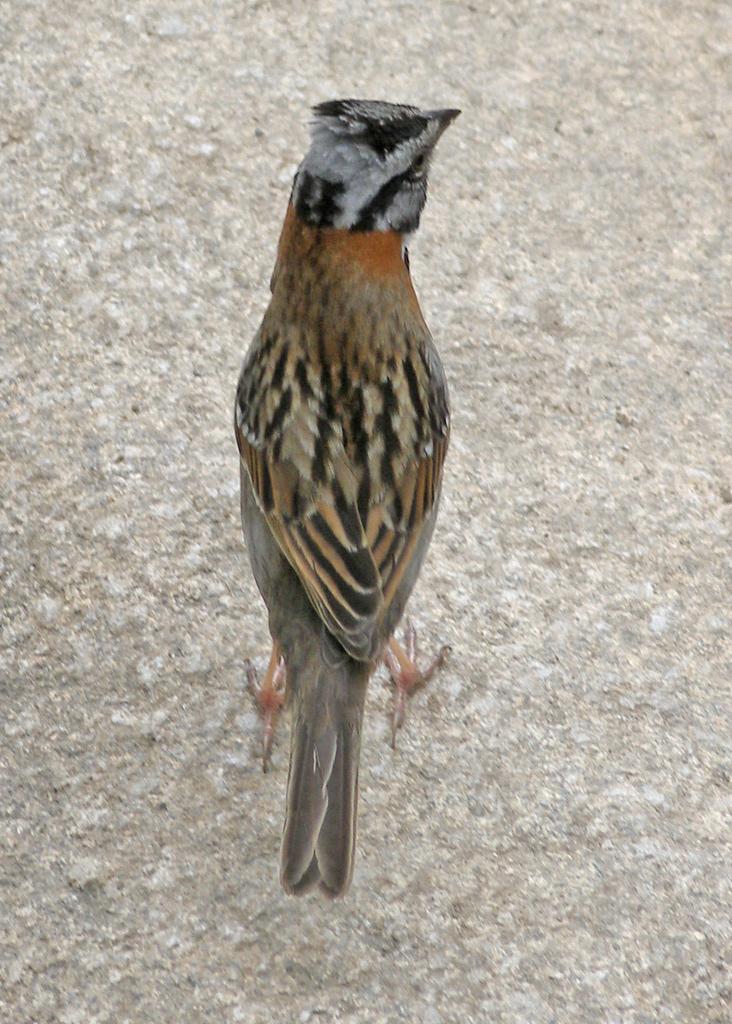How would you summarize this image in a sentence or two? In this picture there is a bird in the center of the image. 